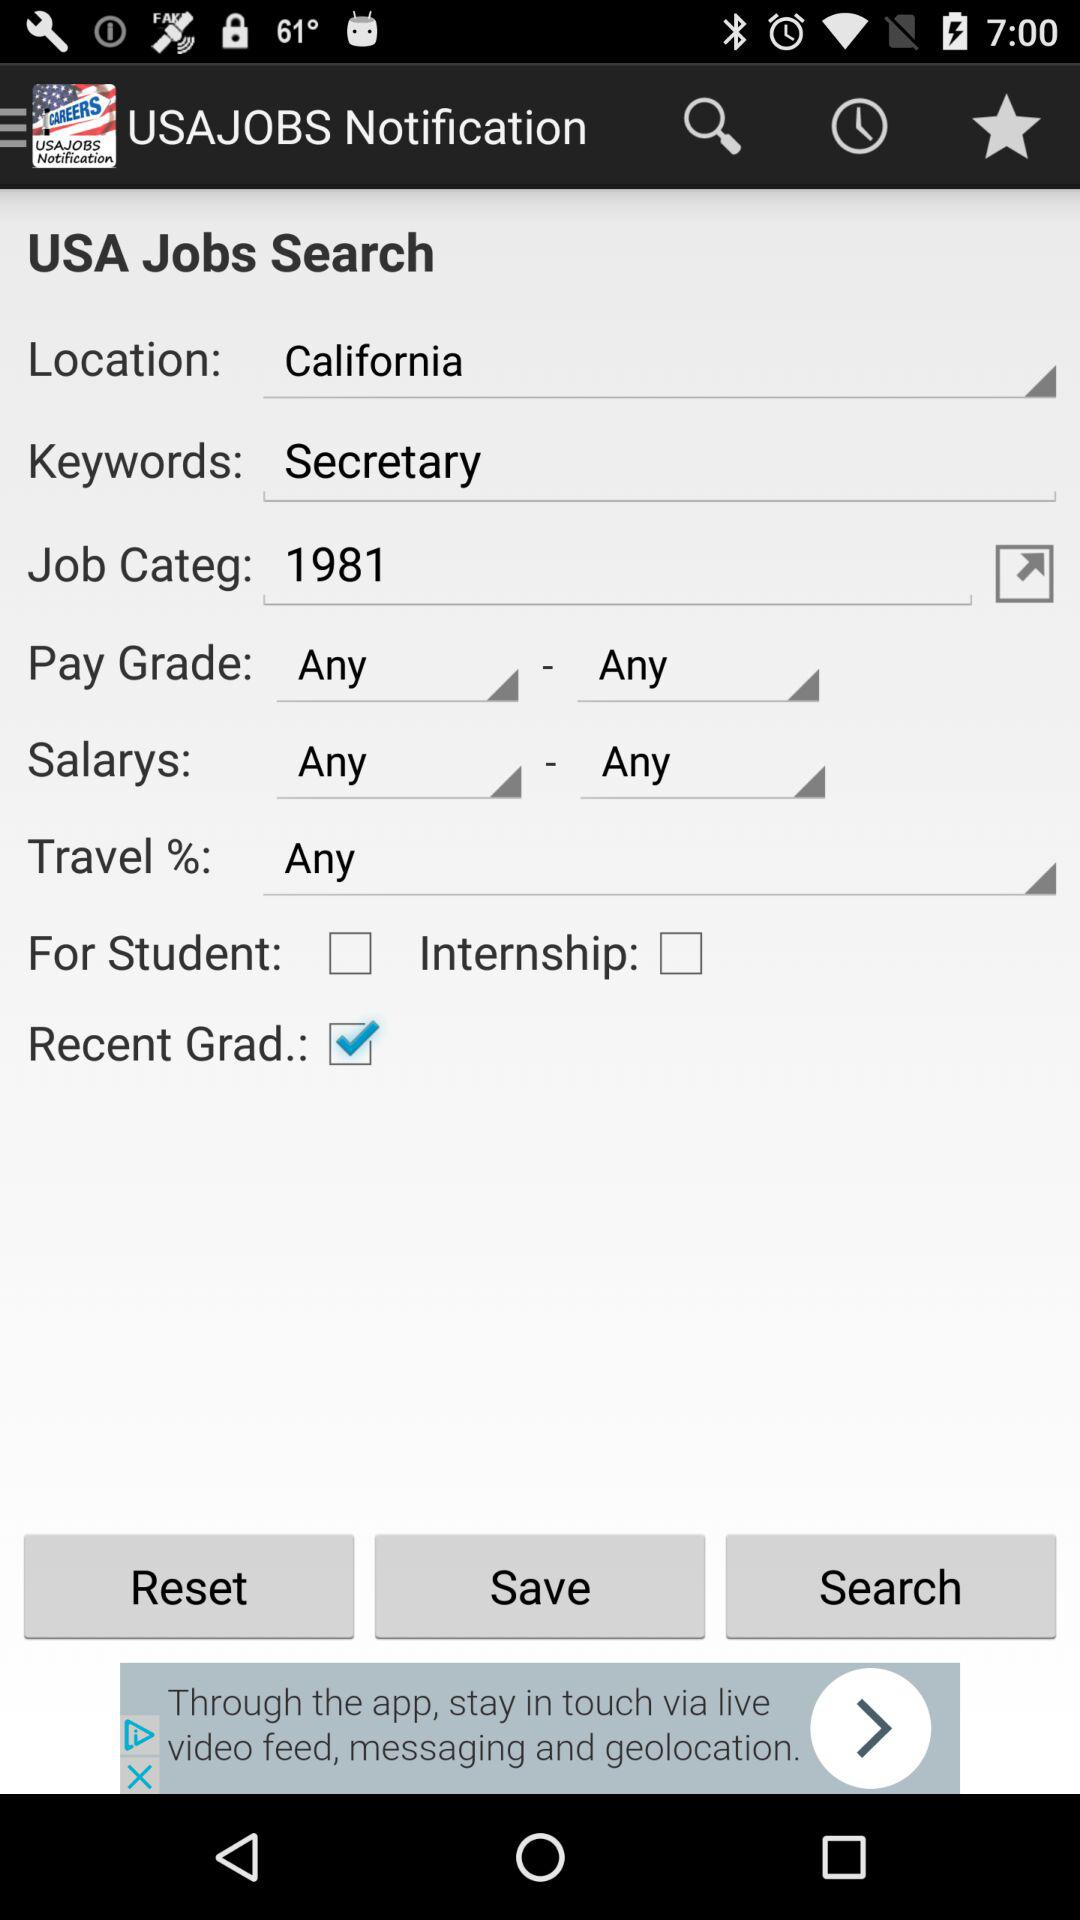Which location is selected? The selected location is California. 